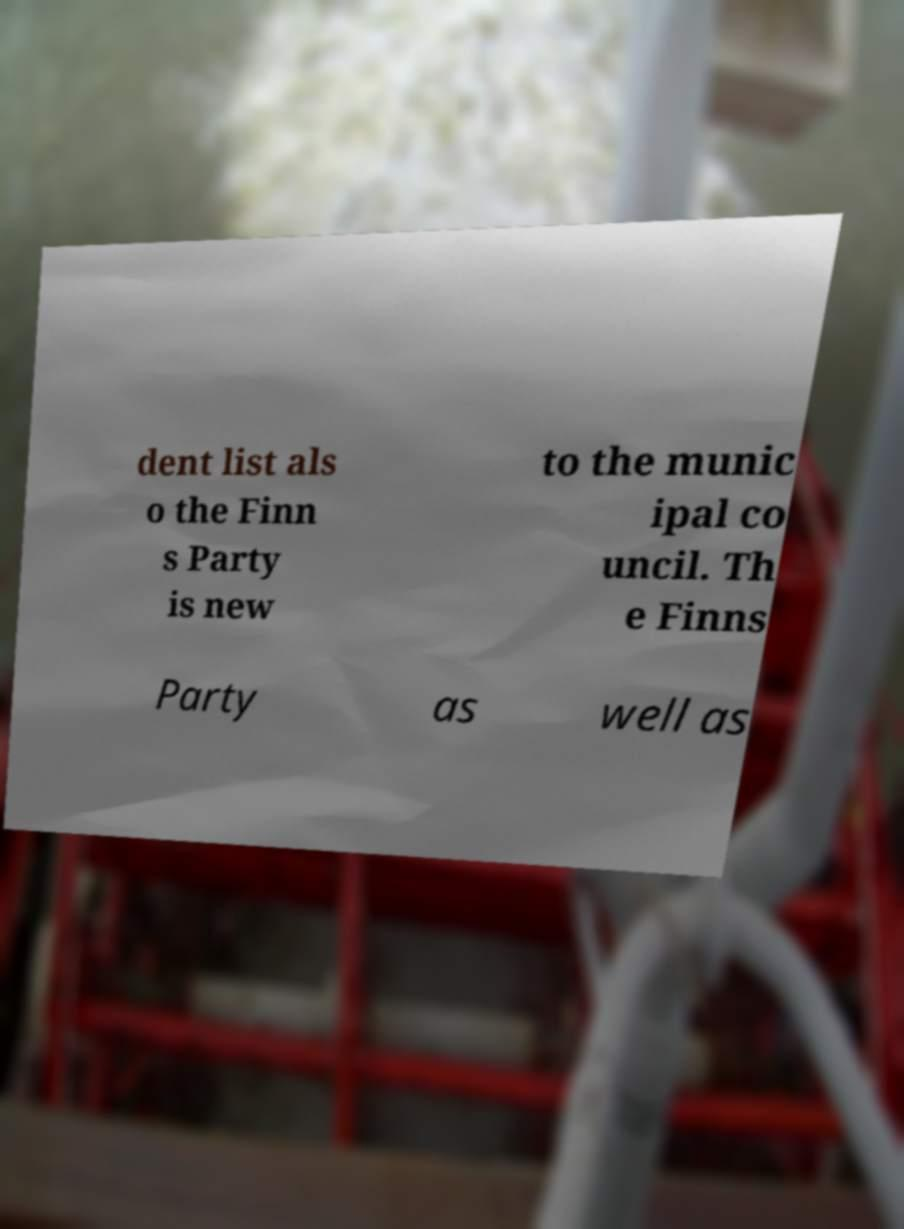For documentation purposes, I need the text within this image transcribed. Could you provide that? dent list als o the Finn s Party is new to the munic ipal co uncil. Th e Finns Party as well as 